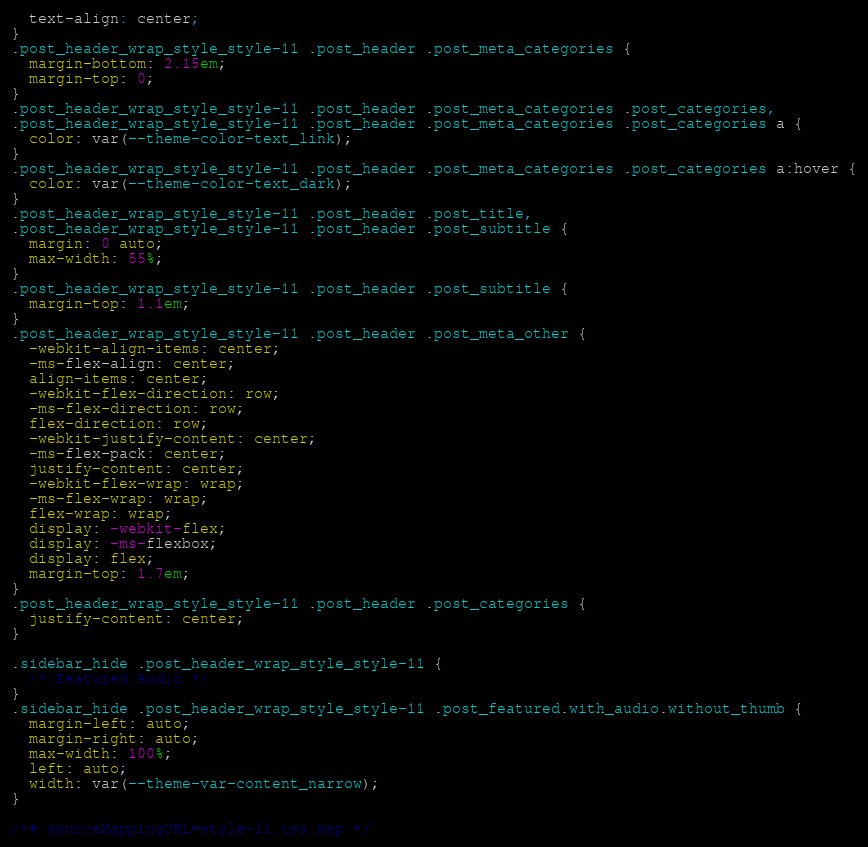Convert code to text. <code><loc_0><loc_0><loc_500><loc_500><_CSS_>  text-align: center;
}
.post_header_wrap_style_style-11 .post_header .post_meta_categories {
  margin-bottom: 2.15em;
  margin-top: 0;
}
.post_header_wrap_style_style-11 .post_header .post_meta_categories .post_categories,
.post_header_wrap_style_style-11 .post_header .post_meta_categories .post_categories a {
  color: var(--theme-color-text_link);
}
.post_header_wrap_style_style-11 .post_header .post_meta_categories .post_categories a:hover {
  color: var(--theme-color-text_dark);
}
.post_header_wrap_style_style-11 .post_header .post_title,
.post_header_wrap_style_style-11 .post_header .post_subtitle {
  margin: 0 auto;
  max-width: 55%;
}
.post_header_wrap_style_style-11 .post_header .post_subtitle {
  margin-top: 1.1em;
}
.post_header_wrap_style_style-11 .post_header .post_meta_other {
  -webkit-align-items: center;
  -ms-flex-align: center;
  align-items: center;
  -webkit-flex-direction: row;
  -ms-flex-direction: row;
  flex-direction: row;
  -webkit-justify-content: center;
  -ms-flex-pack: center;
  justify-content: center;
  -webkit-flex-wrap: wrap;
  -ms-flex-wrap: wrap;
  flex-wrap: wrap;
  display: -webkit-flex;
  display: -ms-flexbox;
  display: flex;
  margin-top: 1.7em;
}
.post_header_wrap_style_style-11 .post_header .post_categories {
  justify-content: center;
}

.sidebar_hide .post_header_wrap_style_style-11 {
  /* Featured Audio */
}
.sidebar_hide .post_header_wrap_style_style-11 .post_featured.with_audio.without_thumb {
  margin-left: auto;
  margin-right: auto;
  max-width: 100%;
  left: auto;
  width: var(--theme-var-content_narrow);
}

/*# sourceMappingURL=style-11.css.map */
</code> 